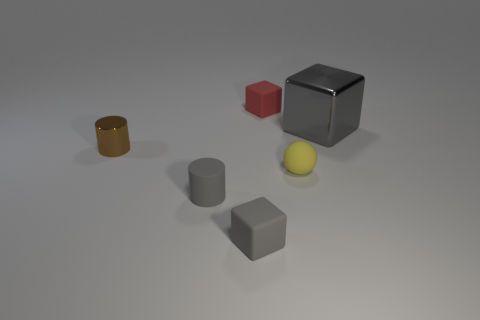Subtract all blue cylinders. How many gray cubes are left? 2 Subtract all small red cubes. How many cubes are left? 2 Add 4 big yellow cylinders. How many objects exist? 10 Subtract all balls. How many objects are left? 5 Subtract all yellow blocks. Subtract all green cylinders. How many blocks are left? 3 Add 6 gray cylinders. How many gray cylinders are left? 7 Add 3 small shiny things. How many small shiny things exist? 4 Subtract 0 cyan cubes. How many objects are left? 6 Subtract all small cubes. Subtract all small red objects. How many objects are left? 3 